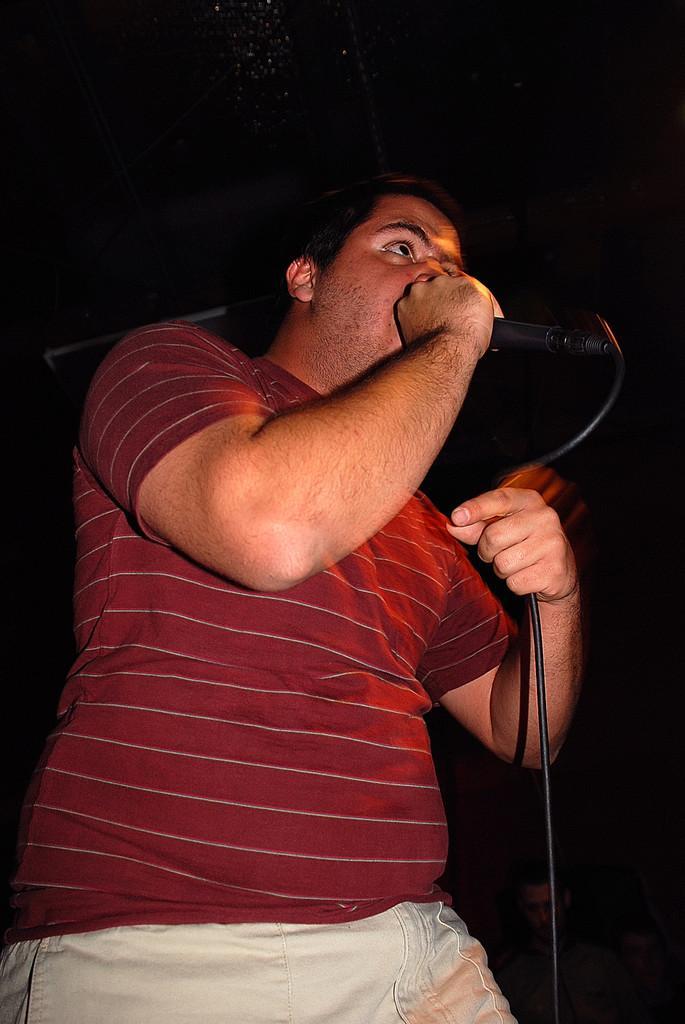How would you summarize this image in a sentence or two? This is the picture of a man wearing red shirt and cream pant is holding a mic in his right hand. 